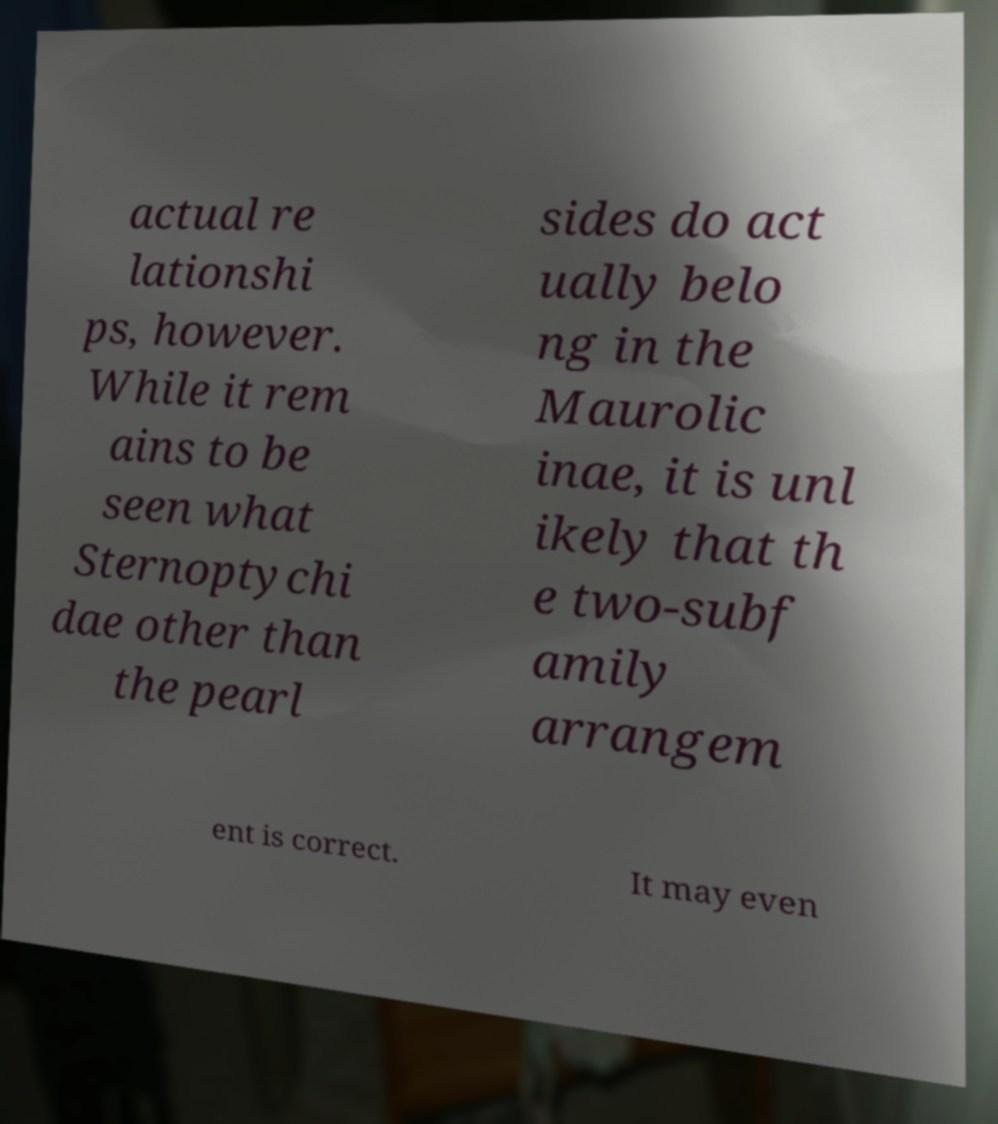I need the written content from this picture converted into text. Can you do that? actual re lationshi ps, however. While it rem ains to be seen what Sternoptychi dae other than the pearl sides do act ually belo ng in the Maurolic inae, it is unl ikely that th e two-subf amily arrangem ent is correct. It may even 